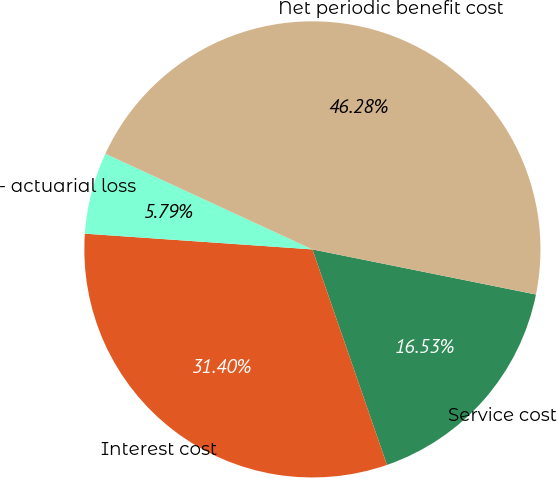Convert chart. <chart><loc_0><loc_0><loc_500><loc_500><pie_chart><fcel>Service cost<fcel>Interest cost<fcel>- actuarial loss<fcel>Net periodic benefit cost<nl><fcel>16.53%<fcel>31.4%<fcel>5.79%<fcel>46.28%<nl></chart> 